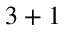Convert formula to latex. <formula><loc_0><loc_0><loc_500><loc_500>3 + 1</formula> 